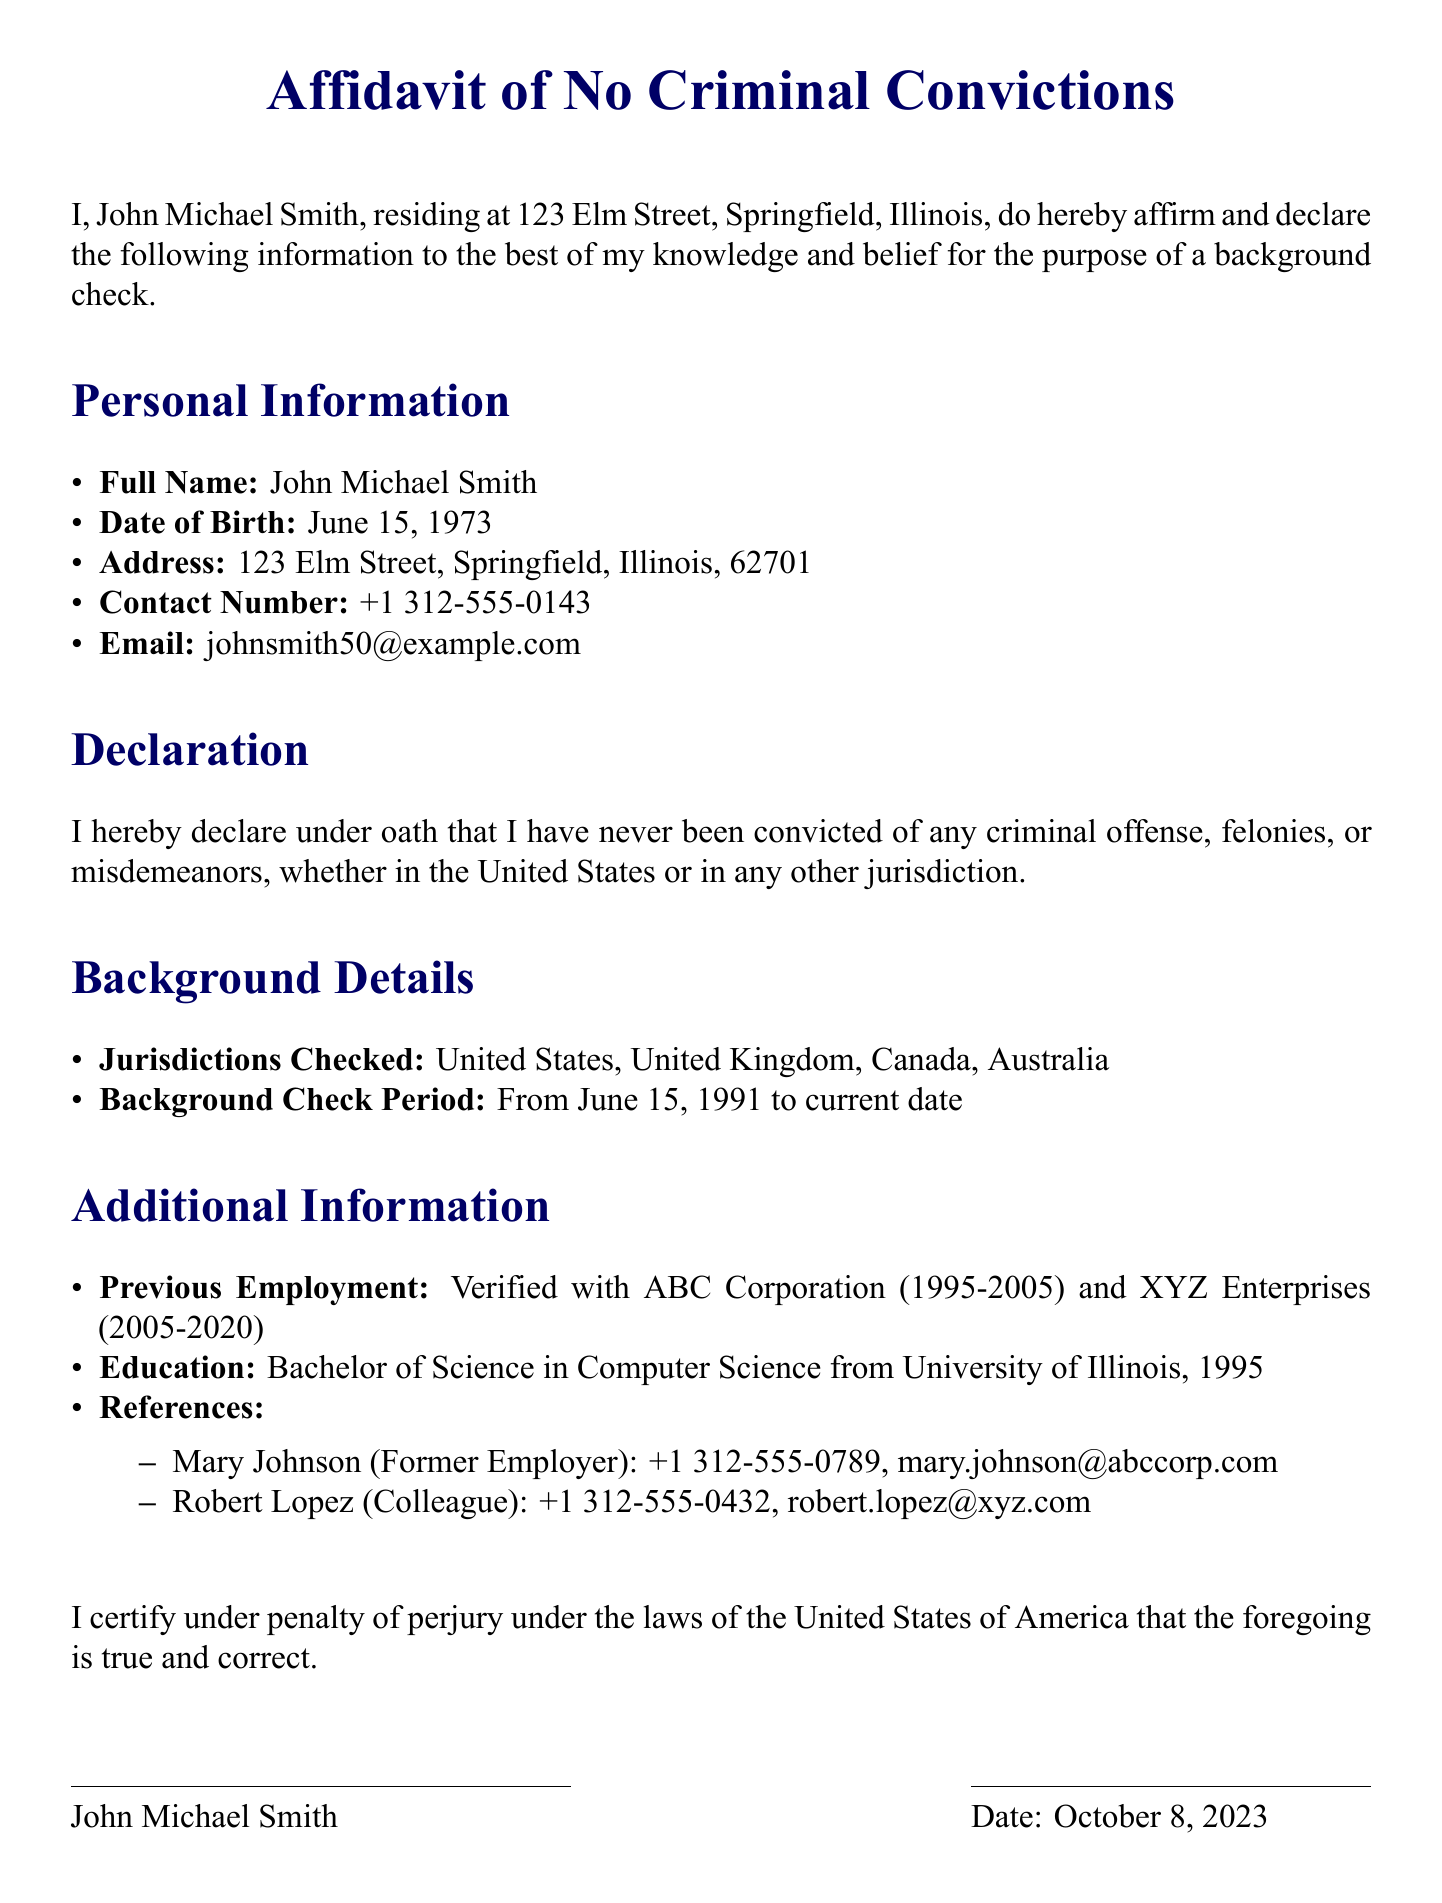What is the full name of the affiant? The full name of the affiant is listed in the personal information section.
Answer: John Michael Smith What is the date of birth of the affiant? The date of birth is provided in the personal information section of the affidavit.
Answer: June 15, 1973 What is the address of the affiant? The address can be found in the personal information section.
Answer: 123 Elm Street, Springfield, Illinois, 62701 What is the background check period covered in the affidavit? The background check period is specified in the background details section.
Answer: From June 15, 1991 to current date What jurisdictions were checked for criminal convictions? The jurisdictions checked for criminal convictions are listed in the background details section.
Answer: United States, United Kingdom, Canada, Australia How many previous employment records are verified? The affidavit mentions two previous employment records in the additional information section.
Answer: Two What degree did the affiant earn and from which institution? The degree and institution are noted in the education section of the affidavit.
Answer: Bachelor of Science in Computer Science from University of Illinois, 1995 Who is the notary public for this affidavit? The notary public's name is provided in the notary section.
Answer: Alice J. Brown What is the expiration date of the notary's commission? The expiration date of the notary's commission is found in the notary section.
Answer: Dec 12, 2026 